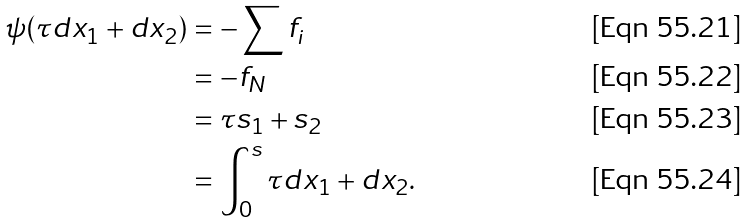Convert formula to latex. <formula><loc_0><loc_0><loc_500><loc_500>\psi ( \tau d x _ { 1 } + d x _ { 2 } ) & = - \sum f _ { i } \\ & = - f _ { N } \\ & = \tau s _ { 1 } + s _ { 2 } \\ & = \int _ { 0 } ^ { s } \tau d x _ { 1 } + d x _ { 2 } .</formula> 